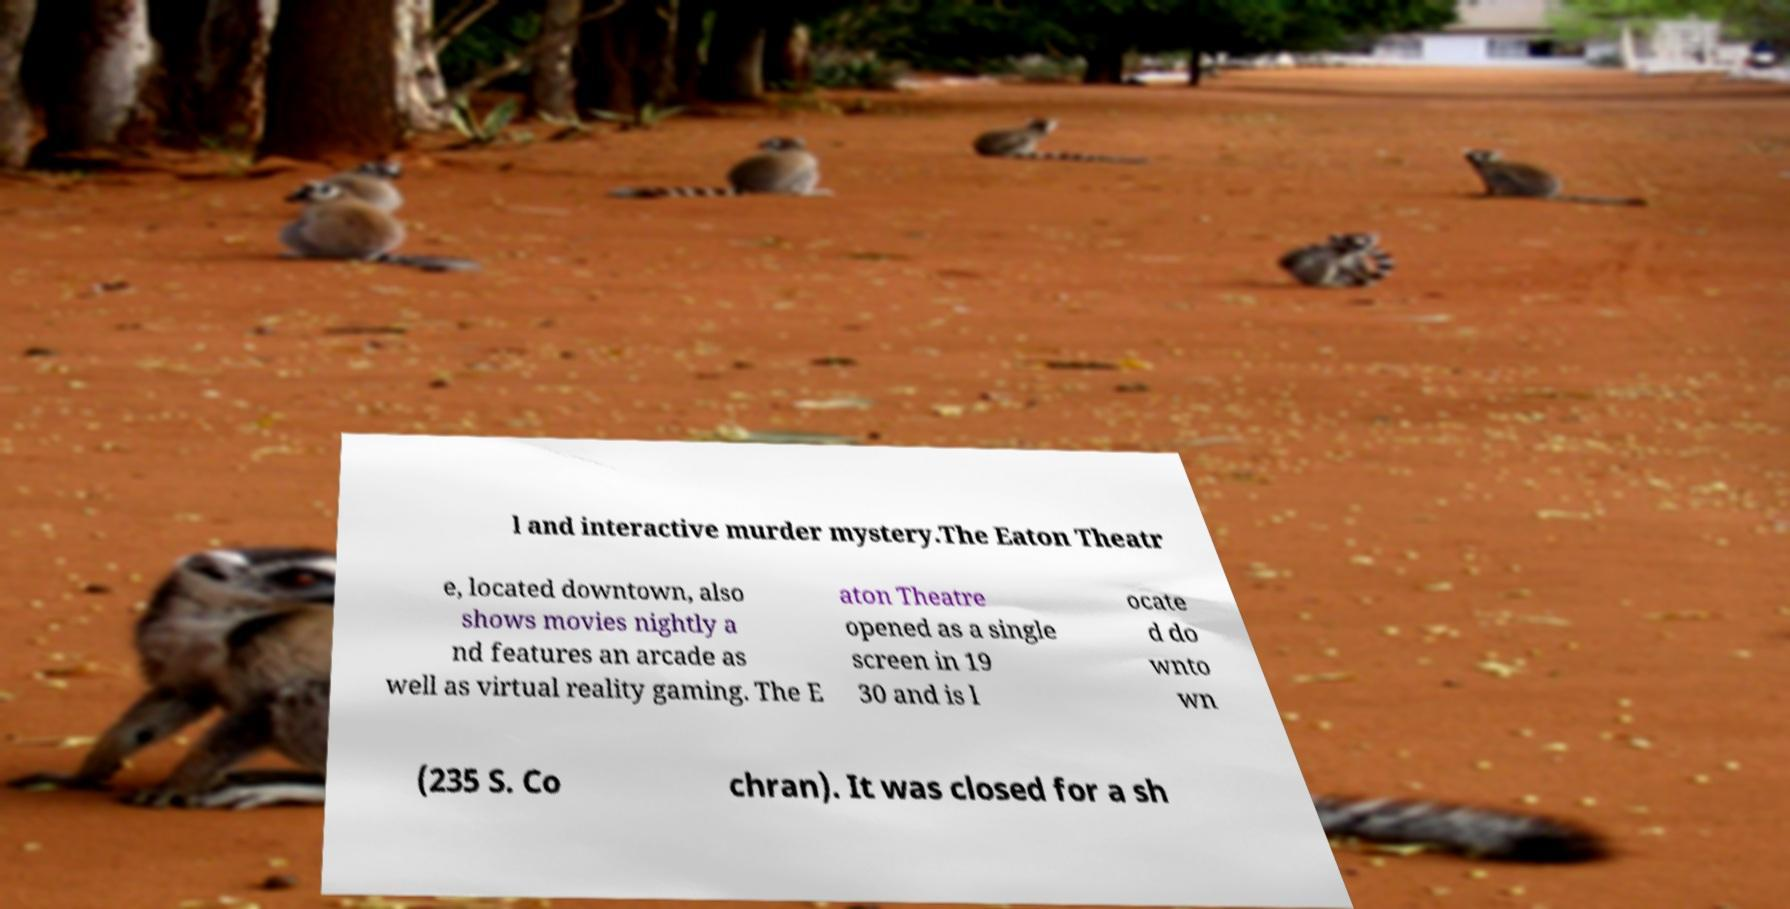There's text embedded in this image that I need extracted. Can you transcribe it verbatim? l and interactive murder mystery.The Eaton Theatr e, located downtown, also shows movies nightly a nd features an arcade as well as virtual reality gaming. The E aton Theatre opened as a single screen in 19 30 and is l ocate d do wnto wn (235 S. Co chran). It was closed for a sh 